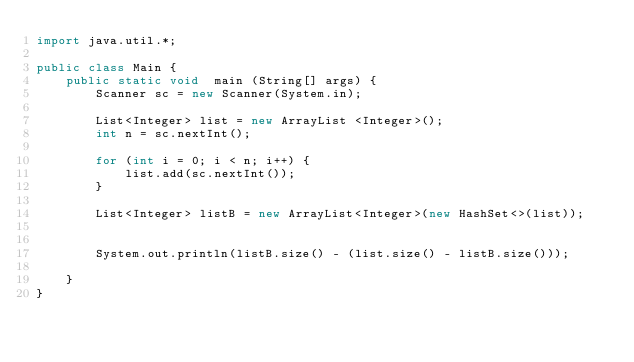<code> <loc_0><loc_0><loc_500><loc_500><_Java_>import java.util.*;

public class Main {
    public static void  main (String[] args) {
        Scanner sc = new Scanner(System.in);
        
        List<Integer> list = new ArrayList <Integer>();
        int n = sc.nextInt();
        
        for (int i = 0; i < n; i++) {
            list.add(sc.nextInt());
        }
        
        List<Integer> listB = new ArrayList<Integer>(new HashSet<>(list));
        
        
        System.out.println(listB.size() - (list.size() - listB.size()));
        
    }
}</code> 